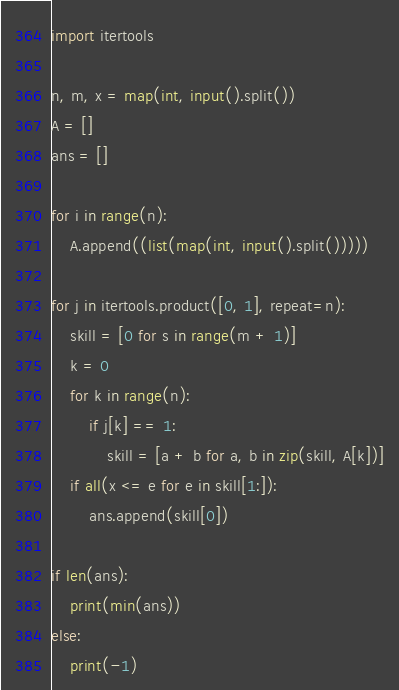Convert code to text. <code><loc_0><loc_0><loc_500><loc_500><_Python_>import itertools

n, m, x = map(int, input().split())
A = []
ans = []

for i in range(n):
    A.append((list(map(int, input().split()))))

for j in itertools.product([0, 1], repeat=n):
    skill = [0 for s in range(m + 1)]
    k = 0
    for k in range(n):
        if j[k] == 1:
            skill = [a + b for a, b in zip(skill, A[k])]
    if all(x <= e for e in skill[1:]):
        ans.append(skill[0])

if len(ans):
    print(min(ans))
else:
    print(-1)</code> 